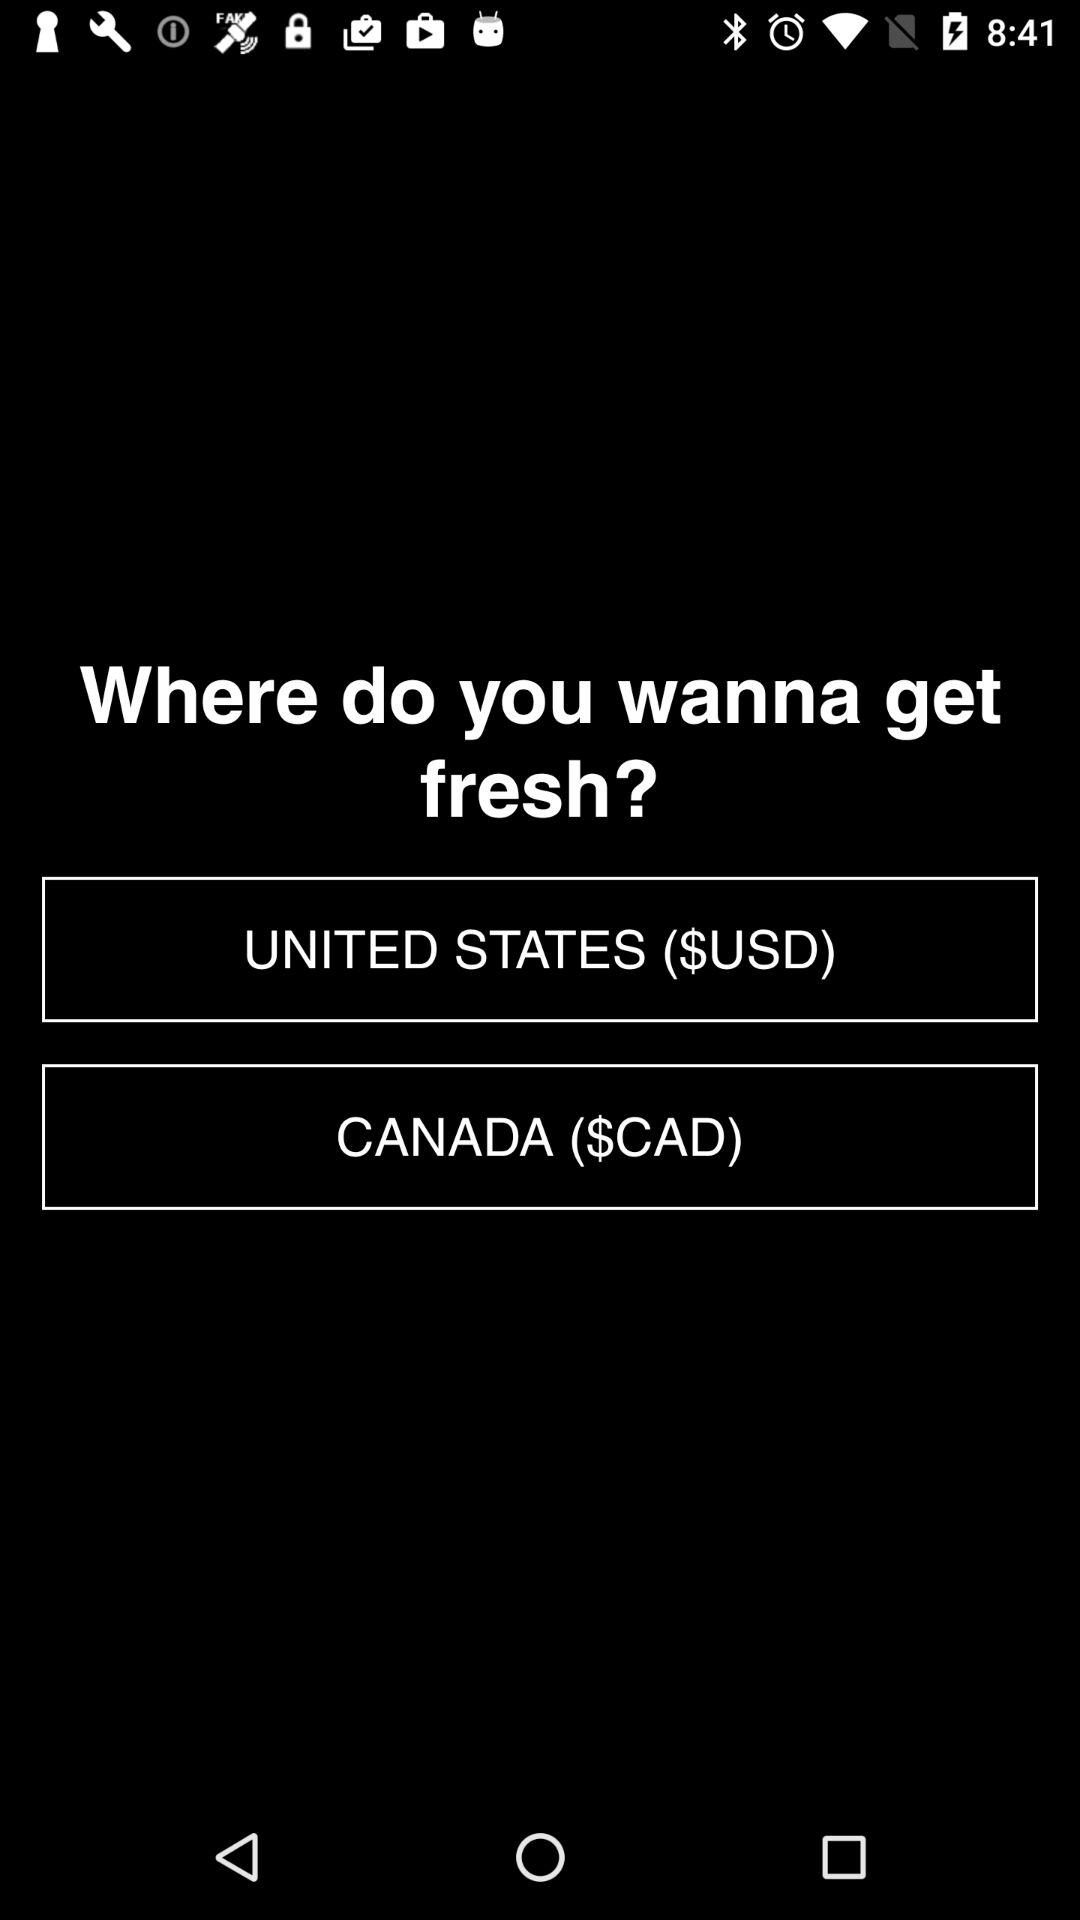What is the currency of Canada? The currency of Canada is the Canadian dollar. 